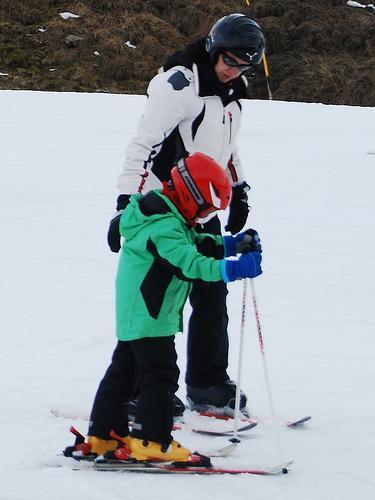How many people are wearing sunglasses?
Give a very brief answer. 1. 